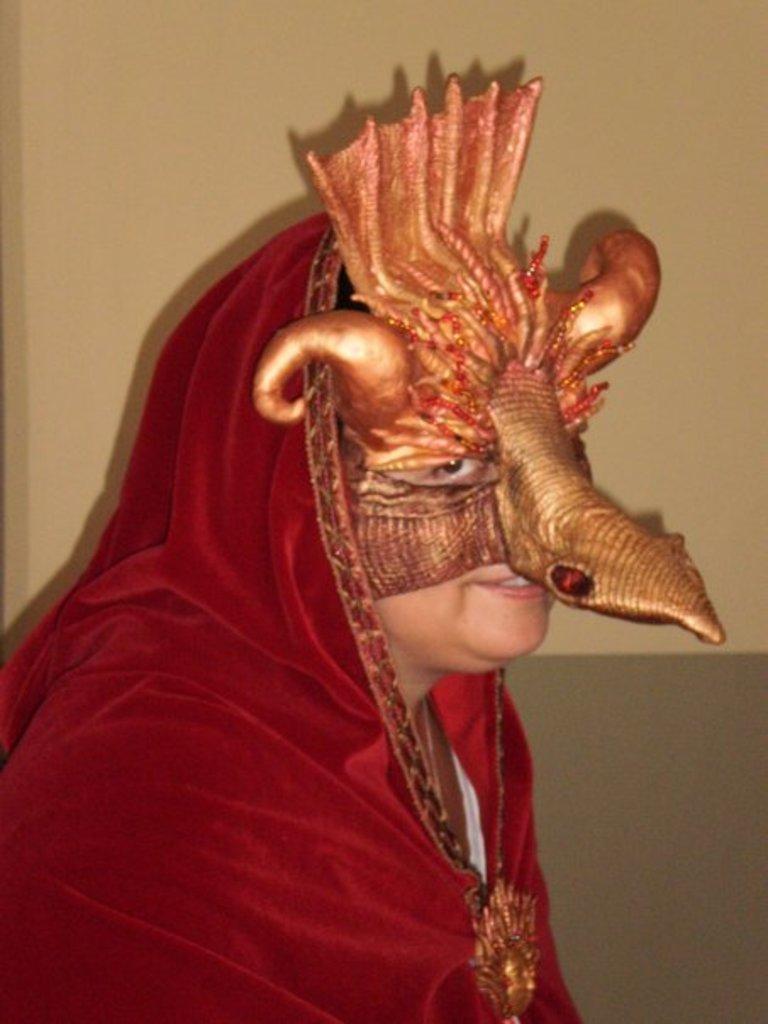In one or two sentences, can you explain what this image depicts? In this picture there is a person wore costume. In the background of the image we can see wall. 